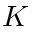<formula> <loc_0><loc_0><loc_500><loc_500>K</formula> 